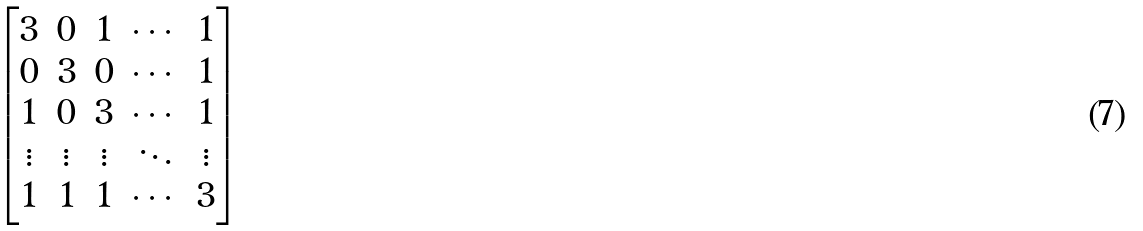<formula> <loc_0><loc_0><loc_500><loc_500>\begin{bmatrix} 3 & 0 & 1 & \cdots & 1 \\ 0 & 3 & 0 & \cdots & 1 \\ 1 & 0 & 3 & \cdots & 1 \\ \vdots & \vdots & \vdots & \ddots & \vdots \\ 1 & 1 & 1 & \cdots & 3 \end{bmatrix}</formula> 